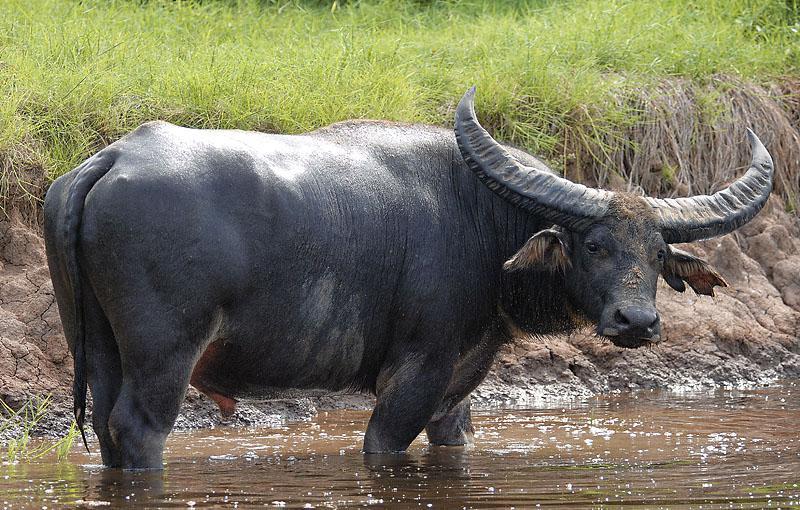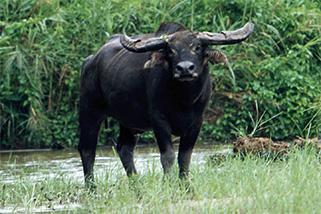The first image is the image on the left, the second image is the image on the right. Analyze the images presented: Is the assertion "The image on the left contains only one water buffalo." valid? Answer yes or no. Yes. The first image is the image on the left, the second image is the image on the right. Assess this claim about the two images: "Each set of images contains exactly three ruminants, regardless of specie-type.". Correct or not? Answer yes or no. No. 